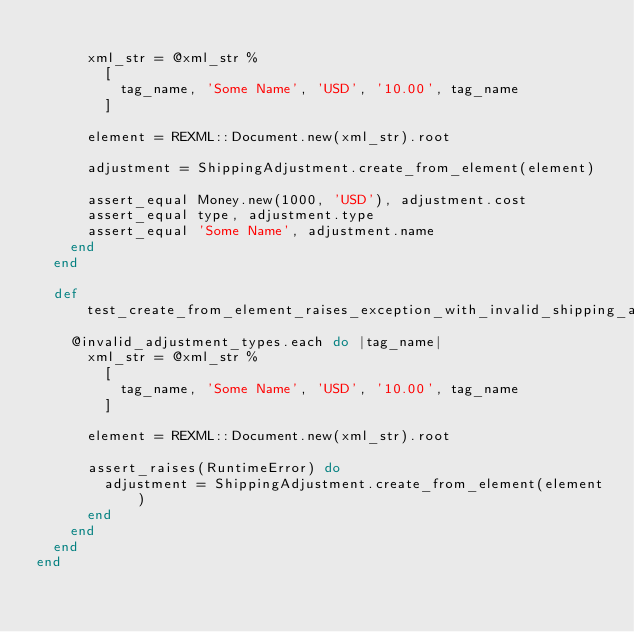<code> <loc_0><loc_0><loc_500><loc_500><_Ruby_>      
      xml_str = @xml_str % 
        [
          tag_name, 'Some Name', 'USD', '10.00', tag_name
        ]
      
      element = REXML::Document.new(xml_str).root
      
      adjustment = ShippingAdjustment.create_from_element(element)
      
      assert_equal Money.new(1000, 'USD'), adjustment.cost
      assert_equal type, adjustment.type
      assert_equal 'Some Name', adjustment.name
    end
  end
  
  def test_create_from_element_raises_exception_with_invalid_shipping_adjustment_types
    @invalid_adjustment_types.each do |tag_name|
      xml_str = @xml_str % 
        [
          tag_name, 'Some Name', 'USD', '10.00', tag_name
        ]
      
      element = REXML::Document.new(xml_str).root
      
      assert_raises(RuntimeError) do
        adjustment = ShippingAdjustment.create_from_element(element)
      end
    end
  end
end</code> 